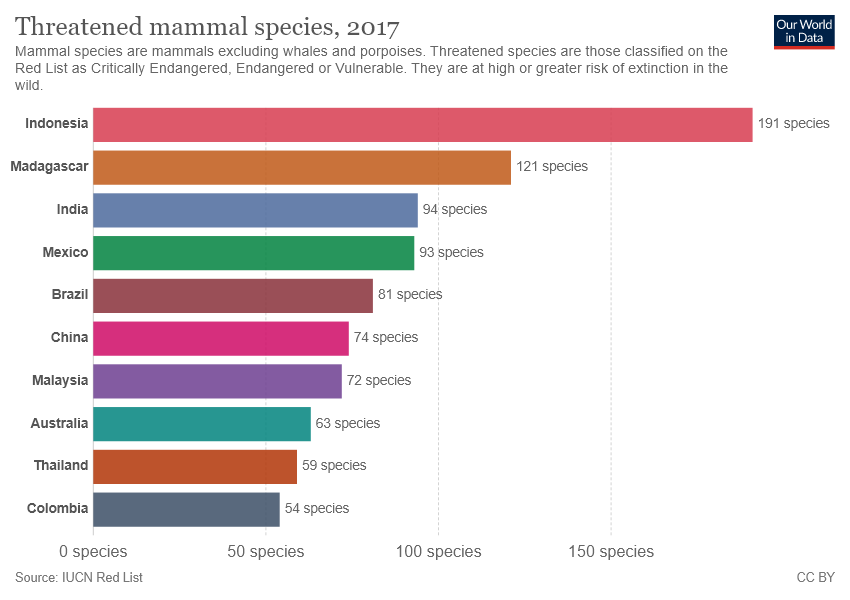Mention a couple of crucial points in this snapshot. Mexico is represented by a green color bar. The number of species varies significantly between countries with the highest and lowest counts. 